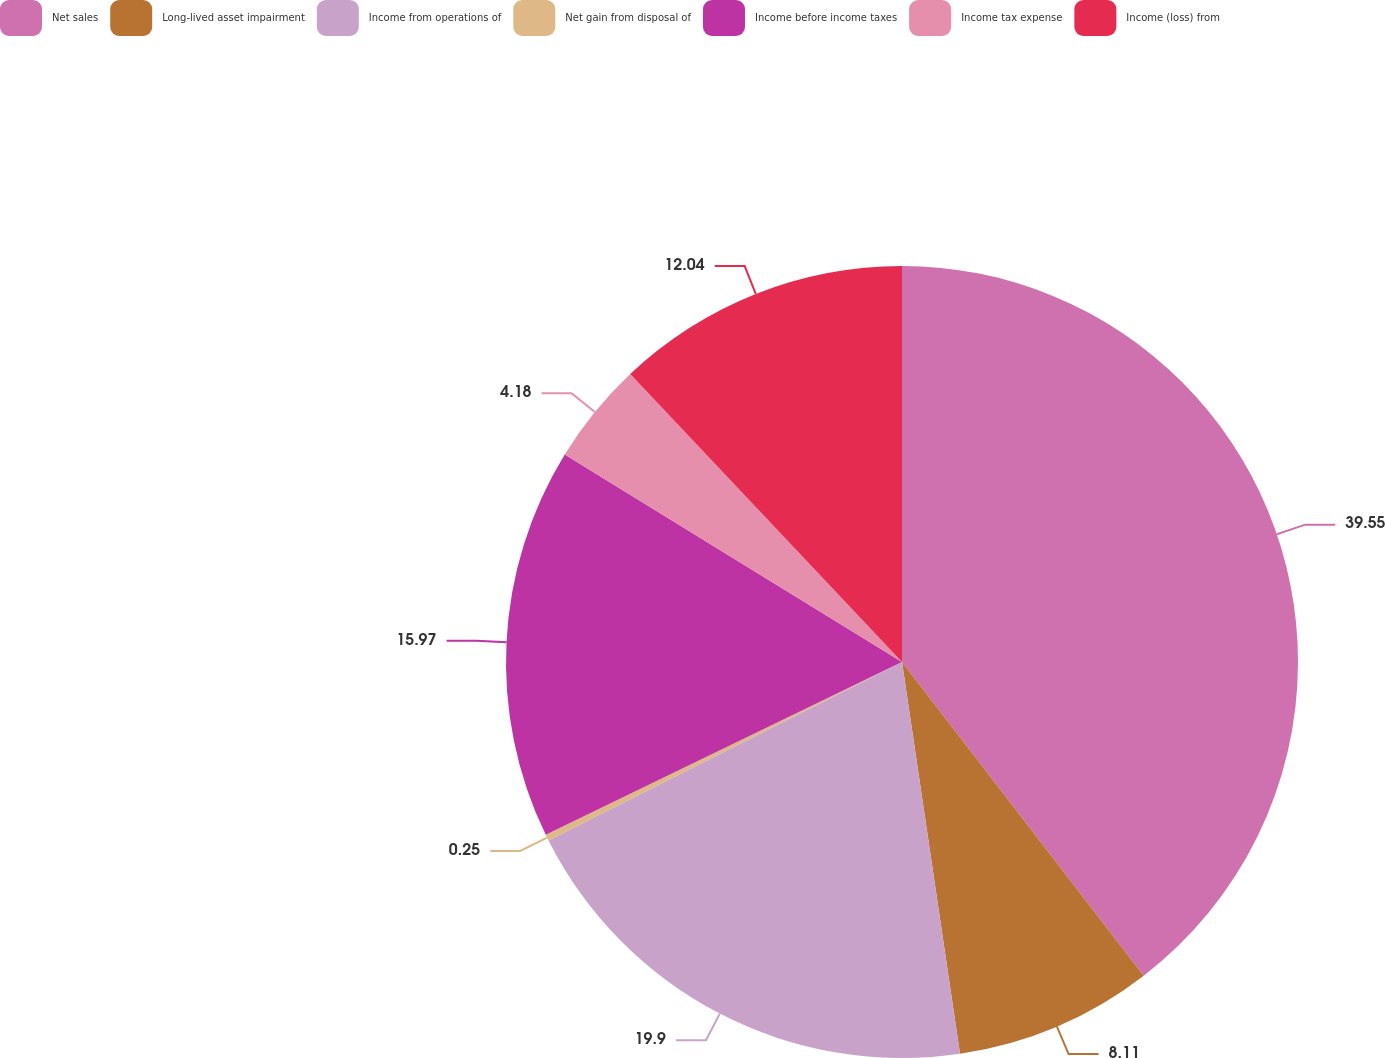Convert chart to OTSL. <chart><loc_0><loc_0><loc_500><loc_500><pie_chart><fcel>Net sales<fcel>Long-lived asset impairment<fcel>Income from operations of<fcel>Net gain from disposal of<fcel>Income before income taxes<fcel>Income tax expense<fcel>Income (loss) from<nl><fcel>39.55%<fcel>8.11%<fcel>19.9%<fcel>0.25%<fcel>15.97%<fcel>4.18%<fcel>12.04%<nl></chart> 